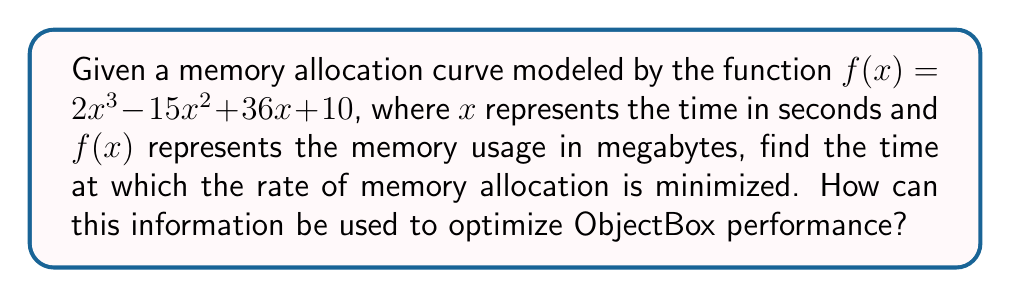Help me with this question. To find the time at which the rate of memory allocation is minimized, we need to follow these steps:

1. The rate of memory allocation is represented by the first derivative of $f(x)$. Let's call this $f'(x)$.

2. Calculate $f'(x)$:
   $f'(x) = 6x^2 - 30x + 36$

3. To find the minimum rate, we need to find where the second derivative $f''(x)$ equals zero:
   $f''(x) = 12x - 30$

4. Set $f''(x) = 0$ and solve for $x$:
   $12x - 30 = 0$
   $12x = 30$
   $x = \frac{30}{12} = 2.5$ seconds

5. To confirm this is a minimum (not a maximum), check if $f'''(x) > 0$:
   $f'''(x) = 12$, which is indeed positive.

6. Therefore, the rate of memory allocation is minimized at $x = 2.5$ seconds.

For ObjectBox optimization:
This information can be used to identify the optimal time for performing memory-intensive operations or garbage collection. By aligning these operations with the point of minimum memory allocation rate (2.5 seconds in this case), developers can minimize the impact on overall system performance. This could involve scheduling background tasks, batch processing, or cache refreshes at or near this time point to take advantage of the slower memory allocation rate.
Answer: 2.5 seconds 